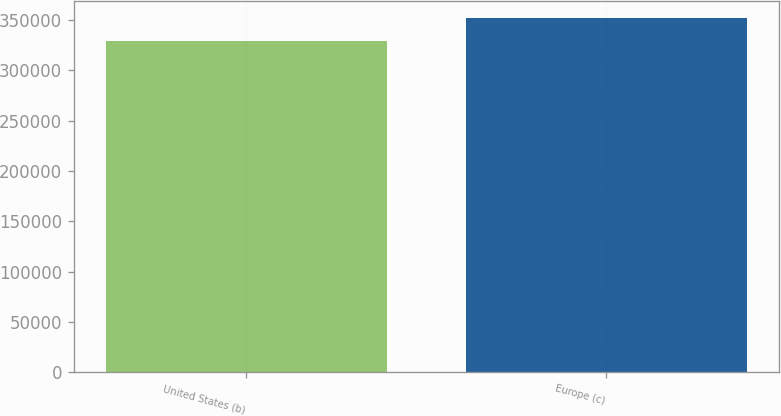Convert chart to OTSL. <chart><loc_0><loc_0><loc_500><loc_500><bar_chart><fcel>United States (b)<fcel>Europe (c)<nl><fcel>328818<fcel>351735<nl></chart> 